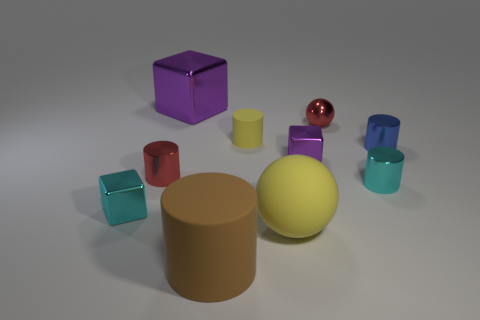How would you describe the overall arrangement and composition of objects in this image? The image displays a neatly arranged collection of geometric shapes featuring various materials and colors, portraying a harmonious balance and contrast. Objects are spaced out evenly, giving a sense of order. 